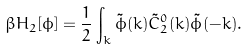Convert formula to latex. <formula><loc_0><loc_0><loc_500><loc_500>\beta H _ { 2 } [ \phi ] = \frac { 1 } { 2 } \int _ { k } \tilde { \phi } ( { k } ) \tilde { C } ^ { 0 } _ { 2 } ( k ) \tilde { \phi } ( - { k } ) .</formula> 